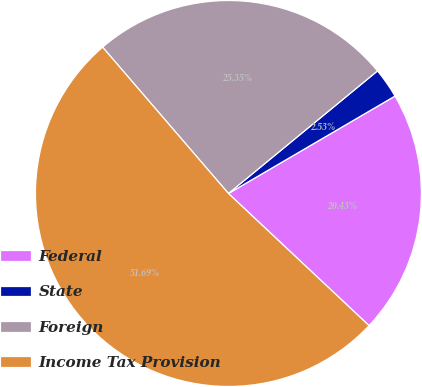Convert chart. <chart><loc_0><loc_0><loc_500><loc_500><pie_chart><fcel>Federal<fcel>State<fcel>Foreign<fcel>Income Tax Provision<nl><fcel>20.43%<fcel>2.53%<fcel>25.35%<fcel>51.69%<nl></chart> 